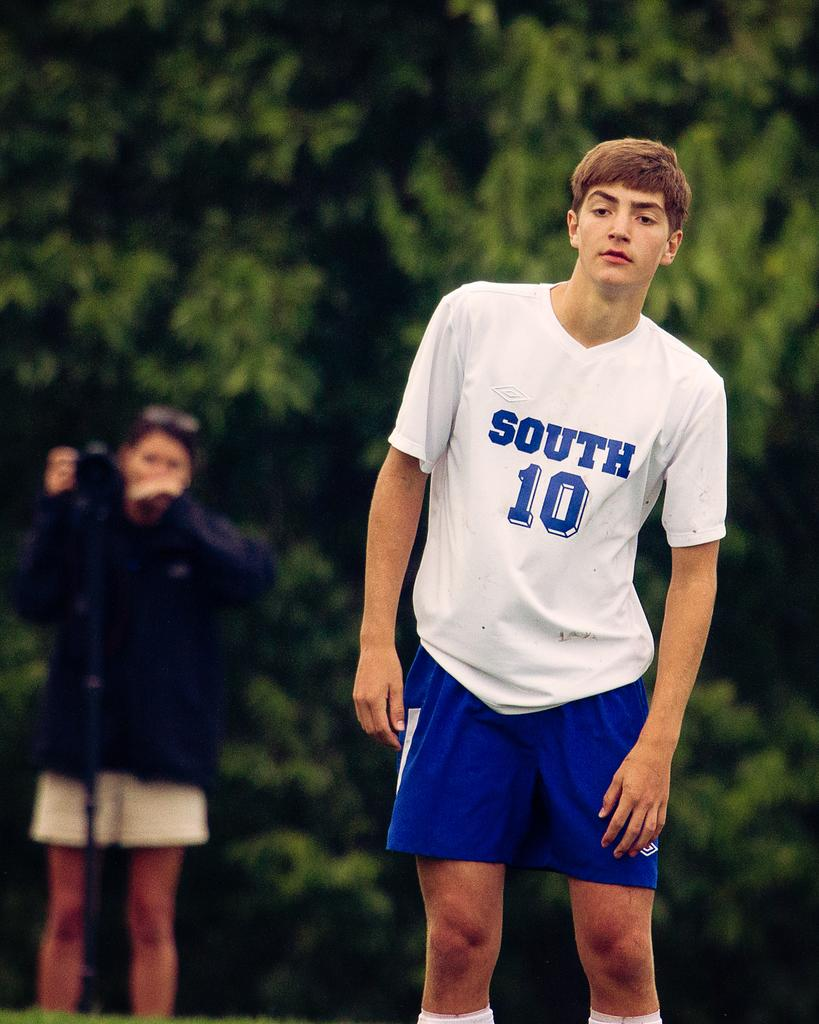<image>
Relay a brief, clear account of the picture shown. The male in the white top is wearing a number 10 on his top. 